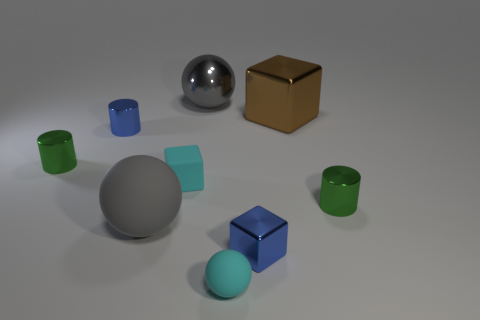There is a rubber sphere that is the same color as the big metallic sphere; what size is it?
Offer a very short reply. Large. There is a large object that is the same color as the metallic sphere; what is it made of?
Your response must be concise. Rubber. Is there a thing of the same color as the rubber cube?
Offer a terse response. Yes. There is a tiny cylinder in front of the small green metallic object that is left of the tiny blue cube; what color is it?
Your answer should be compact. Green. How big is the metallic cylinder left of the blue metallic cylinder?
Provide a short and direct response. Small. Are there any things made of the same material as the cyan block?
Your answer should be compact. Yes. How many other large metallic objects have the same shape as the brown thing?
Make the answer very short. 0. The blue thing in front of the small rubber thing behind the cube in front of the rubber cube is what shape?
Ensure brevity in your answer.  Cube. There is a block that is both behind the blue block and in front of the blue cylinder; what material is it?
Keep it short and to the point. Rubber. Does the green metallic object that is right of the cyan matte ball have the same size as the tiny blue cylinder?
Keep it short and to the point. Yes. 